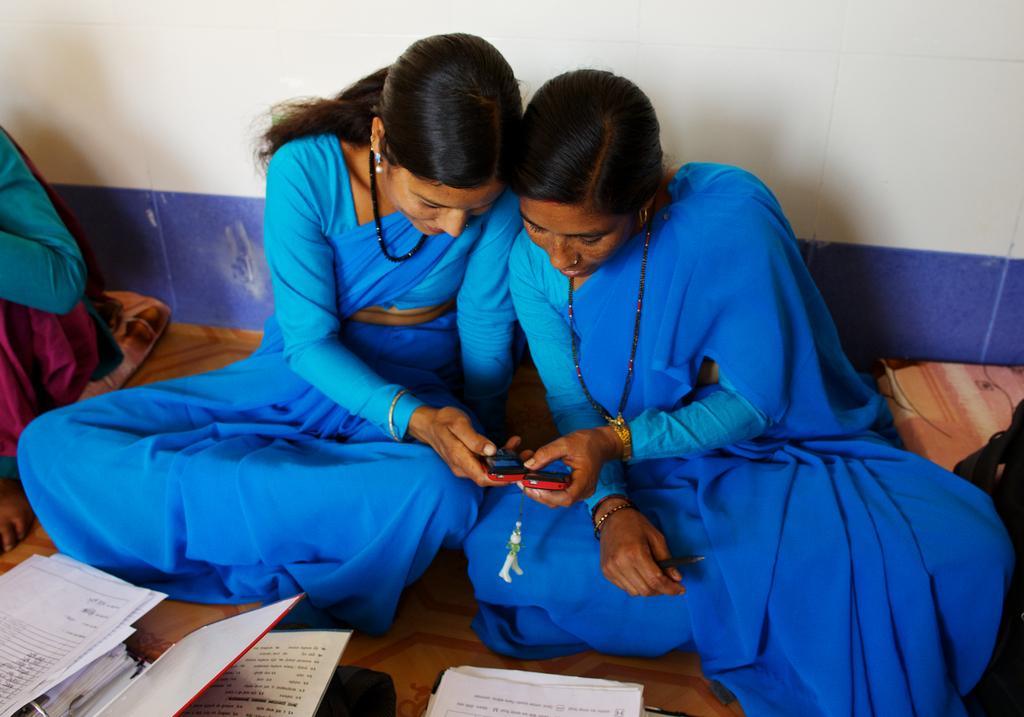Describe this image in one or two sentences. In the picture we can see two women are sitting together and holding the mobile phones and in front of them, we can see some books and papers and in the background we can see the wall. 